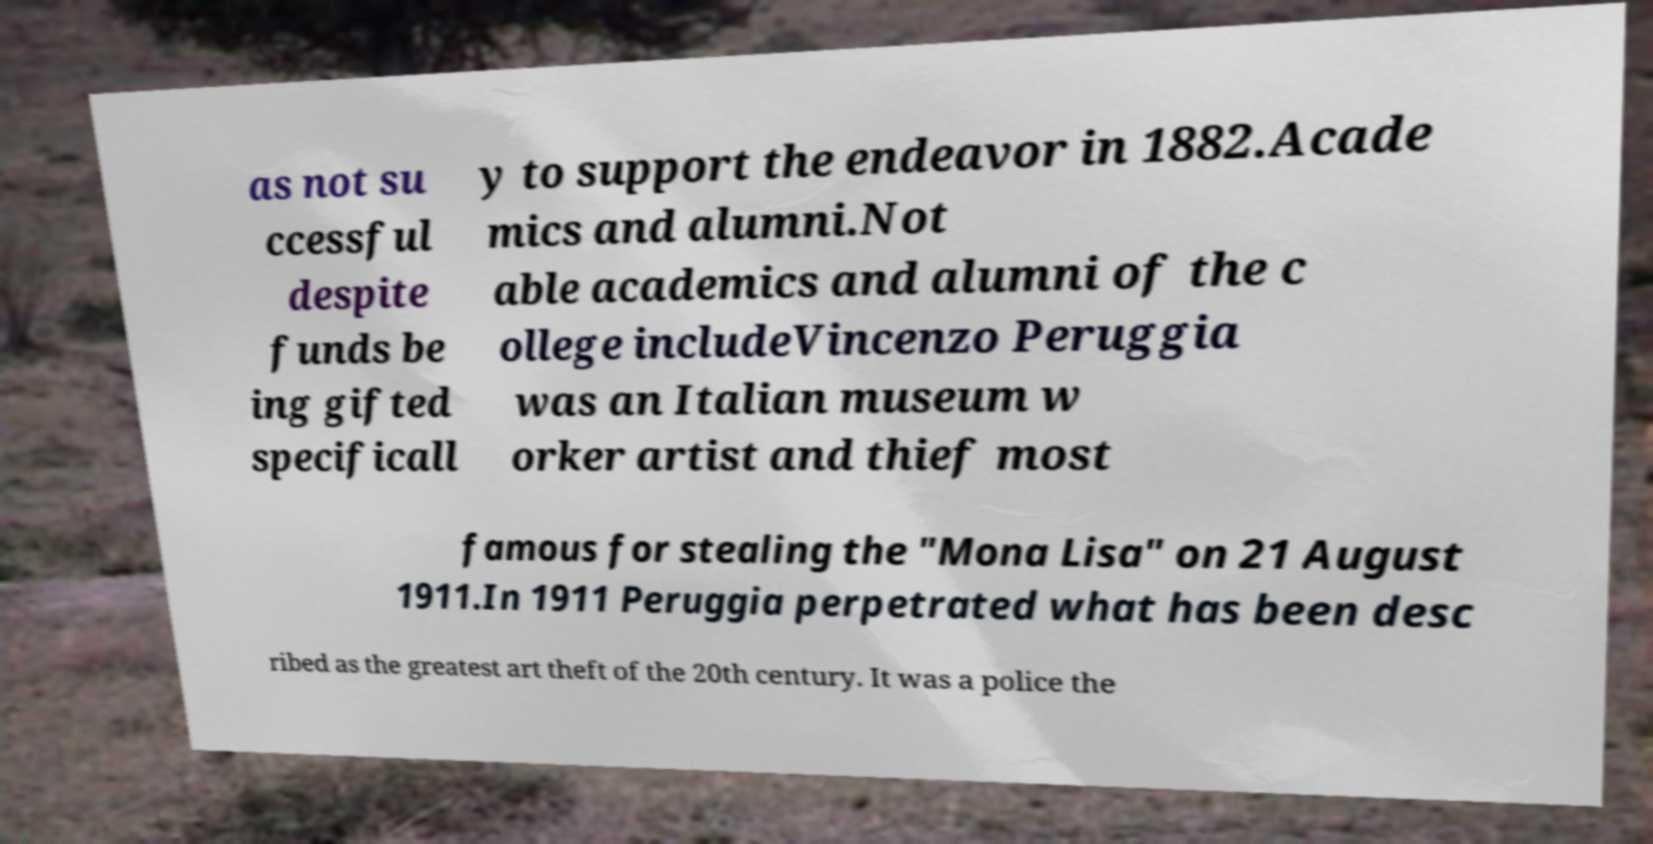There's text embedded in this image that I need extracted. Can you transcribe it verbatim? as not su ccessful despite funds be ing gifted specificall y to support the endeavor in 1882.Acade mics and alumni.Not able academics and alumni of the c ollege includeVincenzo Peruggia was an Italian museum w orker artist and thief most famous for stealing the "Mona Lisa" on 21 August 1911.In 1911 Peruggia perpetrated what has been desc ribed as the greatest art theft of the 20th century. It was a police the 